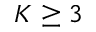<formula> <loc_0><loc_0><loc_500><loc_500>K \geq 3</formula> 